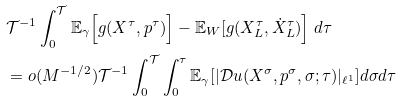Convert formula to latex. <formula><loc_0><loc_0><loc_500><loc_500>& \mathcal { T } ^ { - 1 } \int _ { 0 } ^ { \mathcal { T } } \mathbb { E } _ { \gamma } \Big [ g ( X ^ { \tau } , p ^ { \tau } ) \Big ] - \mathbb { E } _ { W } [ g ( X _ { L } ^ { \tau } , \dot { X } _ { L } ^ { \tau } ) \Big ] \ d \tau \\ & = o ( M ^ { - 1 / 2 } ) \mathcal { T } ^ { - 1 } \int _ { 0 } ^ { \mathcal { T } } \int _ { 0 } ^ { \tau } \mathbb { E } _ { \gamma } [ | \mathcal { D } u ( X ^ { \sigma } , p ^ { \sigma } , \sigma ; \tau ) | _ { \ell ^ { 1 } } ] d \sigma d \tau</formula> 